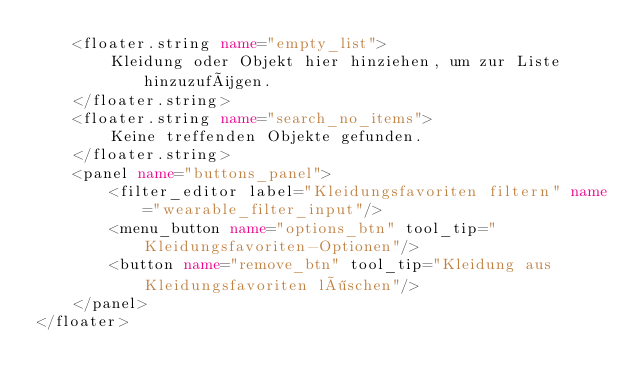<code> <loc_0><loc_0><loc_500><loc_500><_XML_>	<floater.string name="empty_list">
		Kleidung oder Objekt hier hinziehen, um zur Liste hinzuzufügen.
	</floater.string>
	<floater.string name="search_no_items">
		Keine treffenden Objekte gefunden.
	</floater.string>
	<panel name="buttons_panel">
		<filter_editor label="Kleidungsfavoriten filtern" name="wearable_filter_input"/>
		<menu_button name="options_btn" tool_tip="Kleidungsfavoriten-Optionen"/>
		<button name="remove_btn" tool_tip="Kleidung aus Kleidungsfavoriten löschen"/>
	</panel>
</floater>
</code> 